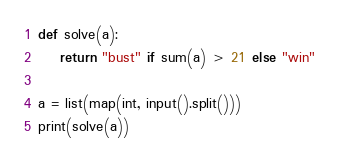Convert code to text. <code><loc_0><loc_0><loc_500><loc_500><_Python_>def solve(a):
    return "bust" if sum(a) > 21 else "win"

a = list(map(int, input().split()))
print(solve(a))</code> 